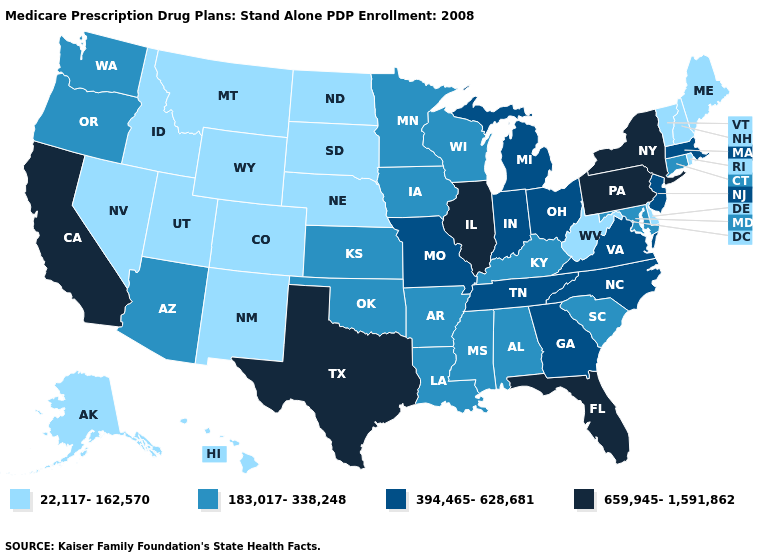What is the value of Texas?
Concise answer only. 659,945-1,591,862. Is the legend a continuous bar?
Concise answer only. No. What is the value of West Virginia?
Quick response, please. 22,117-162,570. Name the states that have a value in the range 659,945-1,591,862?
Short answer required. California, Florida, Illinois, New York, Pennsylvania, Texas. What is the lowest value in states that border Mississippi?
Give a very brief answer. 183,017-338,248. What is the value of Pennsylvania?
Give a very brief answer. 659,945-1,591,862. What is the highest value in the MidWest ?
Be succinct. 659,945-1,591,862. Name the states that have a value in the range 659,945-1,591,862?
Short answer required. California, Florida, Illinois, New York, Pennsylvania, Texas. Name the states that have a value in the range 394,465-628,681?
Keep it brief. Georgia, Indiana, Massachusetts, Michigan, Missouri, North Carolina, New Jersey, Ohio, Tennessee, Virginia. What is the lowest value in the Northeast?
Give a very brief answer. 22,117-162,570. What is the lowest value in states that border California?
Concise answer only. 22,117-162,570. Among the states that border Arkansas , does Mississippi have the lowest value?
Keep it brief. Yes. Among the states that border California , does Arizona have the highest value?
Concise answer only. Yes. What is the lowest value in the USA?
Give a very brief answer. 22,117-162,570. Name the states that have a value in the range 22,117-162,570?
Concise answer only. Alaska, Colorado, Delaware, Hawaii, Idaho, Maine, Montana, North Dakota, Nebraska, New Hampshire, New Mexico, Nevada, Rhode Island, South Dakota, Utah, Vermont, West Virginia, Wyoming. 